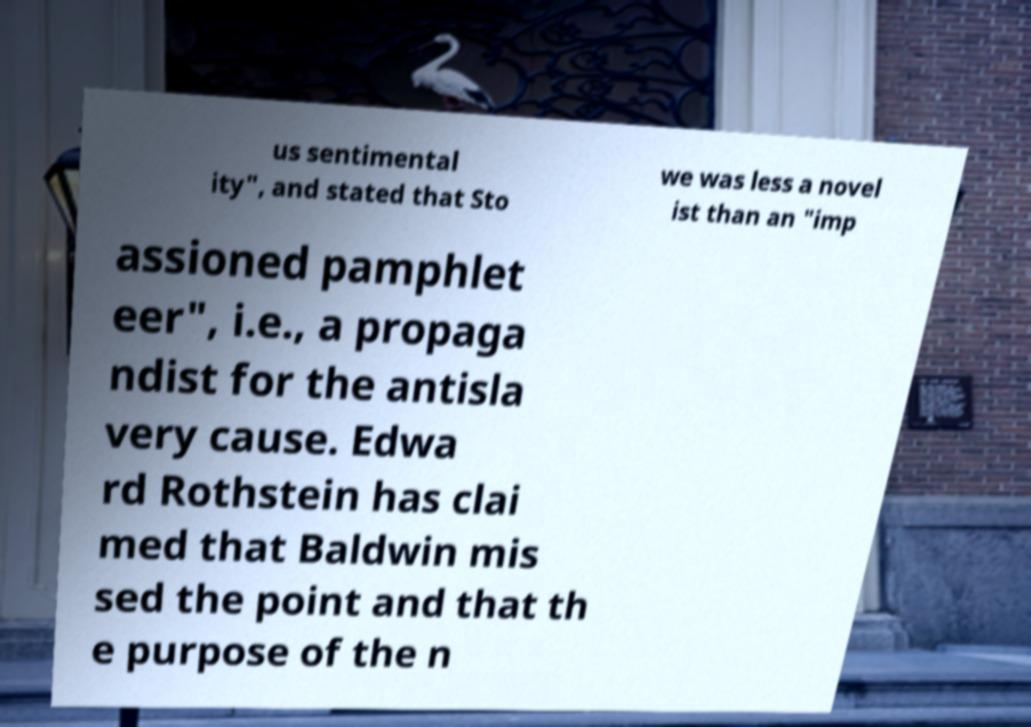Can you read and provide the text displayed in the image?This photo seems to have some interesting text. Can you extract and type it out for me? us sentimental ity", and stated that Sto we was less a novel ist than an "imp assioned pamphlet eer", i.e., a propaga ndist for the antisla very cause. Edwa rd Rothstein has clai med that Baldwin mis sed the point and that th e purpose of the n 